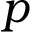<formula> <loc_0><loc_0><loc_500><loc_500>p</formula> 